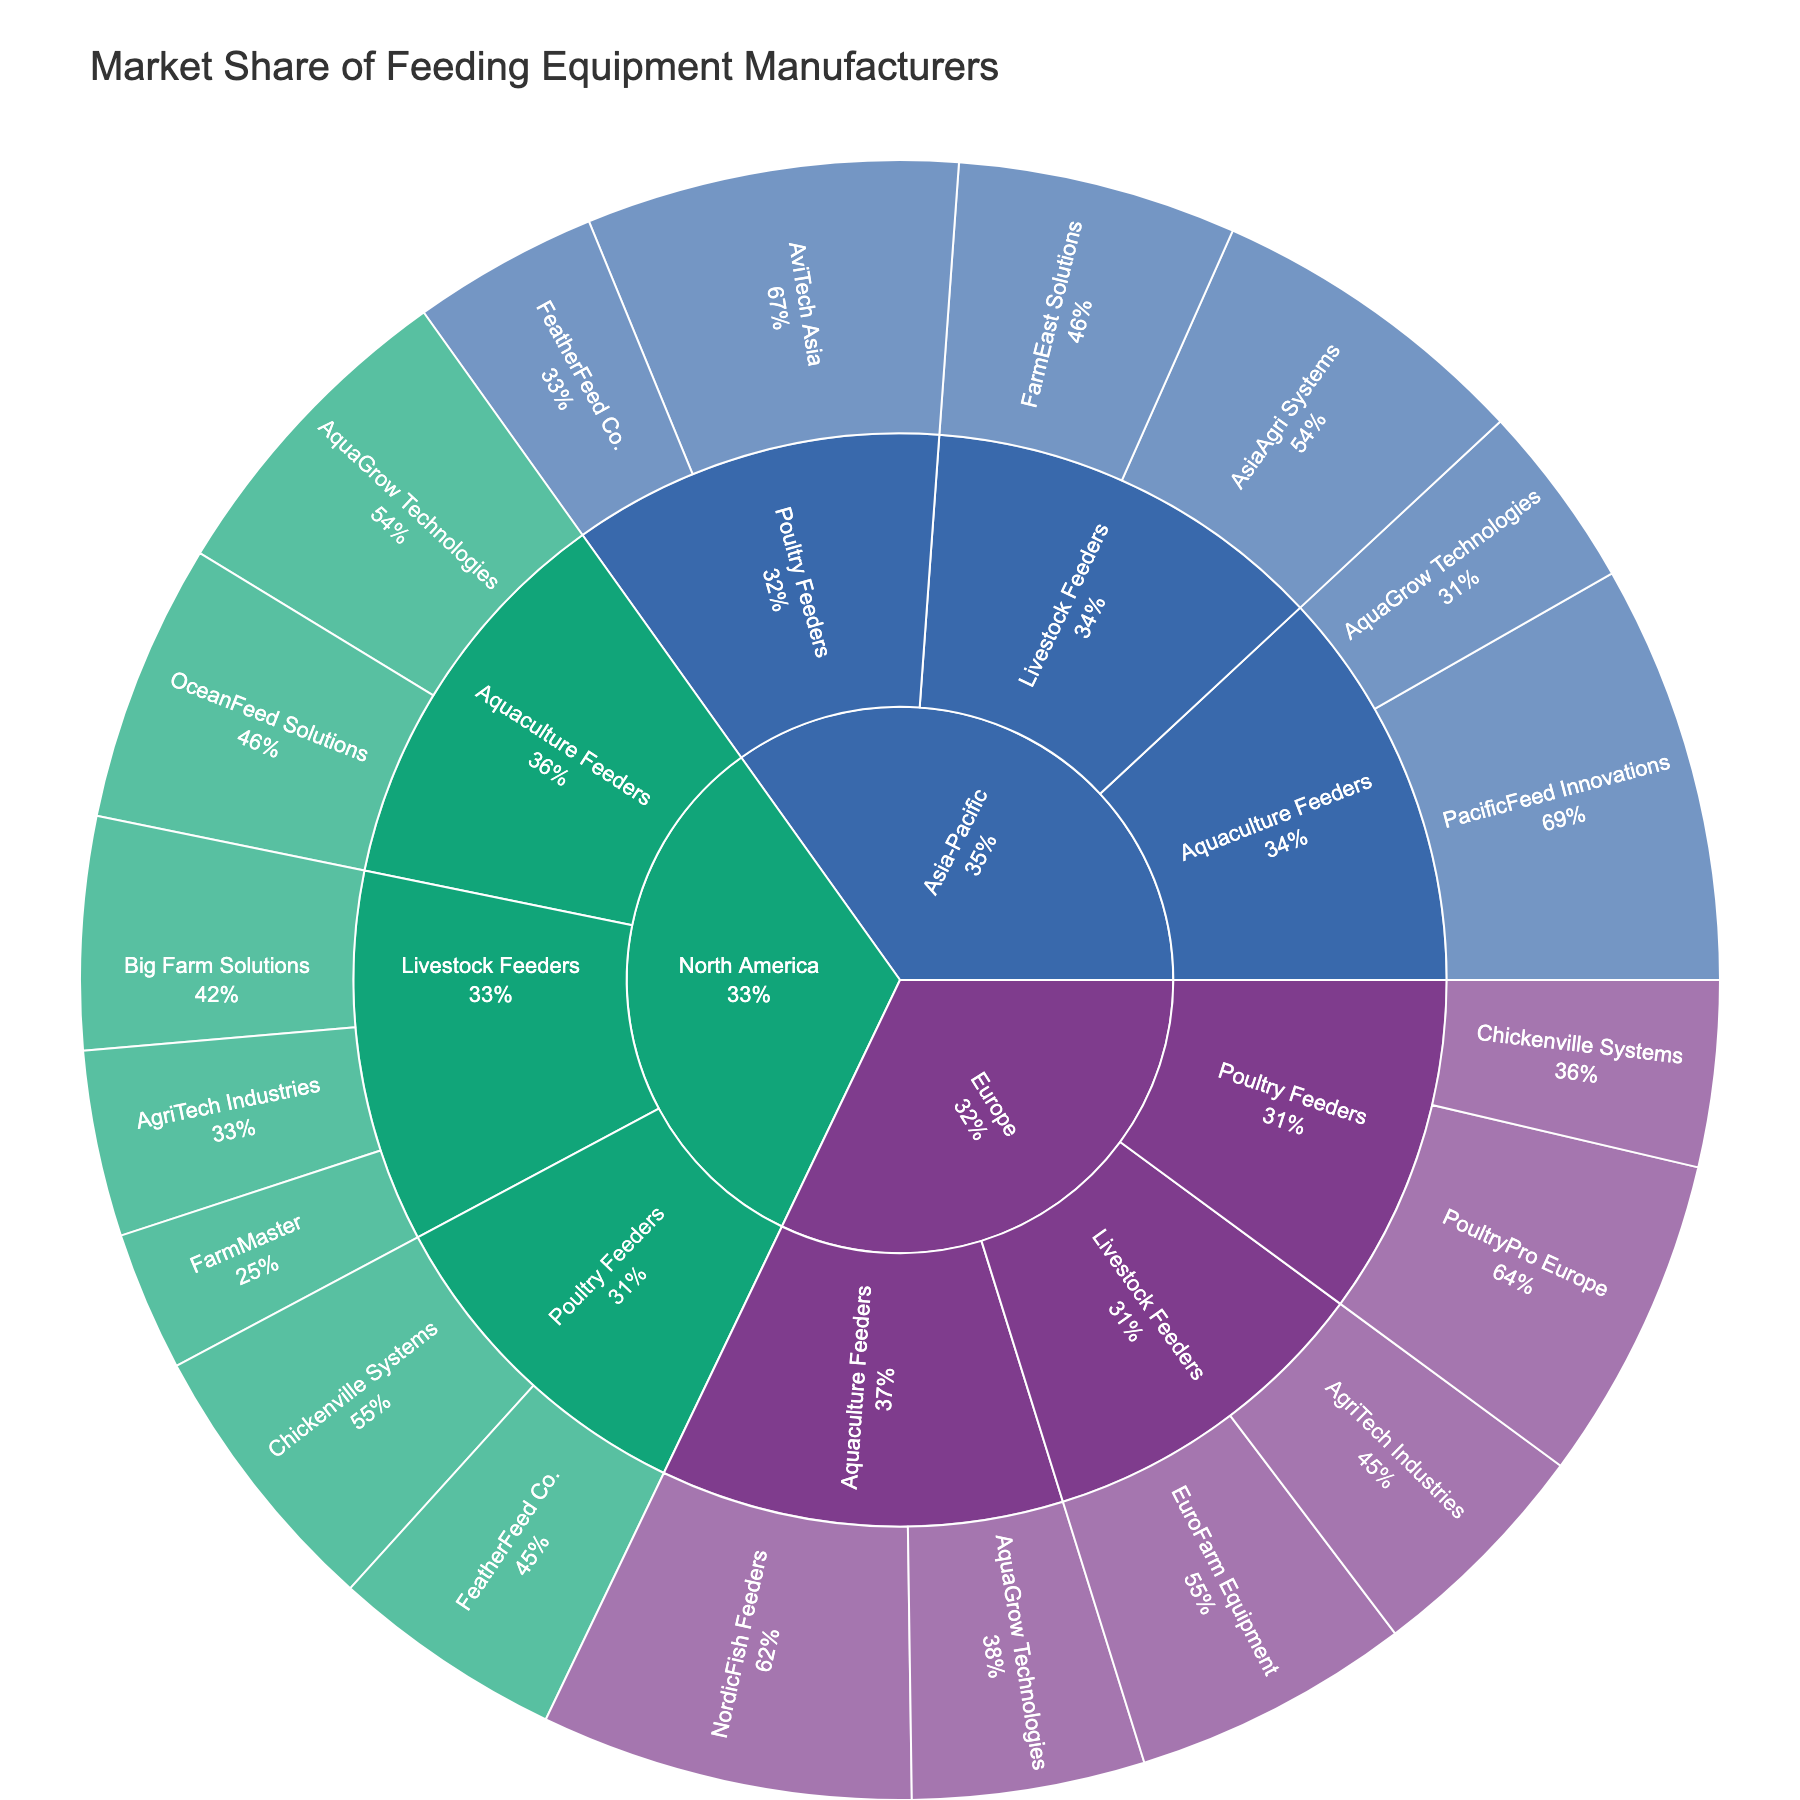what is the title of the figure? The title is usually found at the top of the figure and it describes what the figure represents. In this case, the title of the figure is "Market Share of Feeding Equipment Manufacturers," which is direct and indicates the figure's content.
Answer: Market Share of Feeding Equipment Manufacturers Which region has the highest market share in the Poultry Feeders category in Asia-Pacific? To find the answer, look at the segment of the sunburst plot for the Asia-Pacific region, then locate the segment for the Poultry Feeders category. Among the manufacturers within that segment, identify the one with the largest market share.
Answer: AviTech Asia What is the total market share of AgriTech Industries in North America and Europe for Livestock Feeders? In the sunburst plot, locate the North America and Europe segments. Within each region, find the Livestock Feeders category and then identify the segments for AgriTech Industries. Add their market shares together: 20% in North America and 25% in Europe. Hence, 20 + 25 = 45%.
Answer: 45% Which category has the smallest market share in North America? Scan the segments within the North America region in the sunburst plot. Compare the slices for Livestock Feeders, Poultry Feeders, and Aquaculture Feeders. The smallest market share segment belongs to Livestock Feeders with the percentages of 25%, 20%, and 15% adding up to 60%. Poultry Feeders and Aquaculture Feeders have higher combined percentages.
Answer: Livestock Feeders Compare the market shares of AquaGrow Technologies in the Aquaculture Feeders category across all regions. Which region shows the highest share? To answer this, locate the segments for AquaGrow Technologies within the Aquaculture Feeders category in each region. Compare the percentages: North America (35%), Europe (25%), and Asia-Pacific (20%). Thus, the highest market share for AquaGrow Technologies is in North America.
Answer: North America Describe the market share distribution for Chickenville Systems in the Poultry Feeders category across all regions. Locate Chickenville Systems in the Poultry Feeders category for each region in the sunburst plot. They have 30% in North America, 20% in Europe, and are not present in Asia-Pacific.
Answer: 30% in North America, 20% in Europe Compared to Europe, does North America have a higher or lower total market share in Aquaculture Feeders? Sum the market shares for the Aquaculture Feeders manufacturers in each region. In North America: 35% (AquaGrow Technologies) + 30% (OceanFeed Solutions) = 65%. In Europe: 40% (NordicFish Feeders) + 25% (AquaGrow Technologies) = 65%. Since both regions have the same total market share for Aquaculture Feeders, the answer is neither higher nor lower.
Answer: Same Who has the highest market share in the Europe region for Poultry Feeders? Look for the largest segment within the Poultry Feeders category in the Europe region. The manufacturer with the largest segment is PoultryPro Europe with 35%.
Answer: PoultryPro Europe 